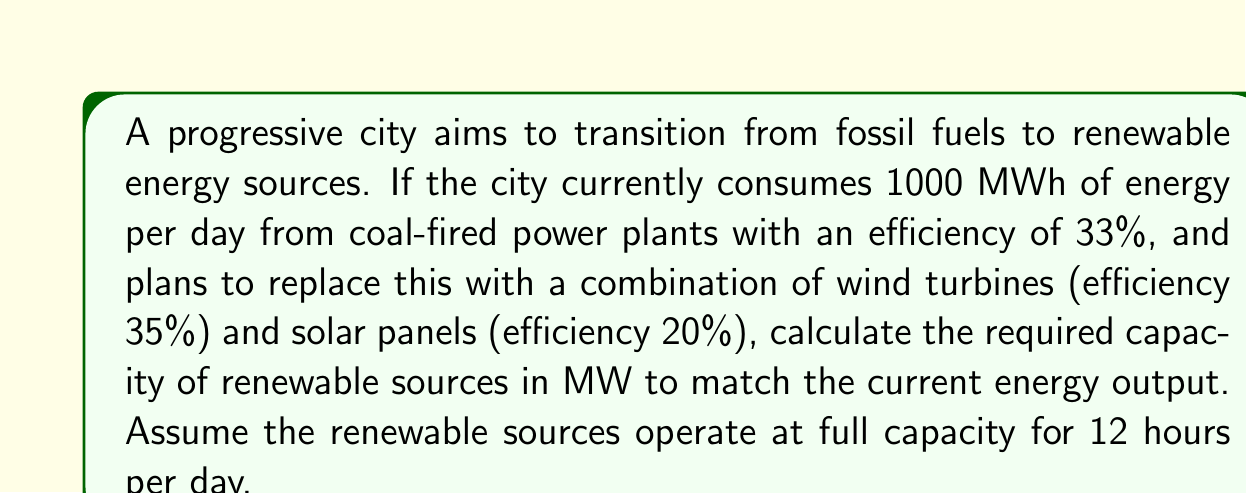Give your solution to this math problem. To solve this problem, we'll follow these steps:

1) First, let's calculate the actual energy output from the coal-fired power plants:
   $$E_{coal} = 1000 \text{ MWh} \times 0.33 = 330 \text{ MWh per day}$$

2) Now, we need to match this energy output with renewable sources. Let's define variables:
   Let $x$ be the capacity of wind turbines in MW
   Let $y$ be the capacity of solar panels in MW

3) We can set up an equation based on the energy output:
   $$(0.35x + 0.20y) \times 12 \text{ hours} = 330 \text{ MWh}$$

4) Simplify the equation:
   $$4.2x + 2.4y = 330$$

5) We can't solve this equation uniquely as we have two unknowns. However, we can find the total capacity required if we assume an equal mix of wind and solar:

   Let $x = y = z$
   Then, $4.2z + 2.4z = 330$
   $6.6z = 330$
   $z = 50$

6) Therefore, the total capacity required is:
   $$\text{Total Capacity} = 2z = 2 \times 50 = 100 \text{ MW}$$

This solution demonstrates that renewable sources, despite their intermittency (assumed 12 hours of operation), can match the energy output of fossil fuels with appropriate capacity planning. It highlights the potential for cleaner energy production, aligning with a liberal perspective critical of fossil fuel dependence.
Answer: 100 MW 